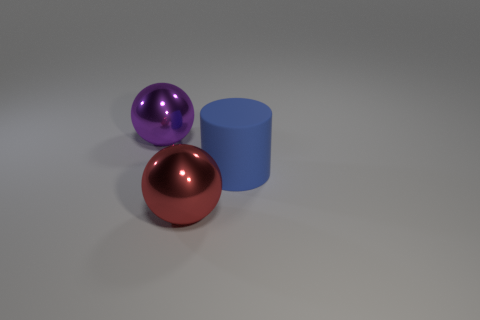Are there more big cylinders that are on the right side of the matte thing than big metallic balls on the right side of the red shiny object?
Offer a very short reply. No. What is the material of the purple ball?
Offer a very short reply. Metal. What shape is the metallic thing in front of the large metal thing behind the big shiny sphere in front of the purple object?
Make the answer very short. Sphere. How many other things are there of the same material as the large red ball?
Offer a very short reply. 1. Is the large sphere to the right of the big purple metallic thing made of the same material as the large thing behind the rubber cylinder?
Offer a terse response. Yes. What number of balls are to the left of the red metallic object and right of the purple sphere?
Keep it short and to the point. 0. Are there any other big metallic things that have the same shape as the red object?
Your response must be concise. Yes. There is a blue matte object that is the same size as the purple sphere; what is its shape?
Your answer should be compact. Cylinder. Are there an equal number of shiny spheres that are behind the red thing and big objects that are behind the big blue cylinder?
Your answer should be compact. Yes. How big is the sphere behind the big metallic object that is in front of the blue rubber cylinder?
Make the answer very short. Large. 